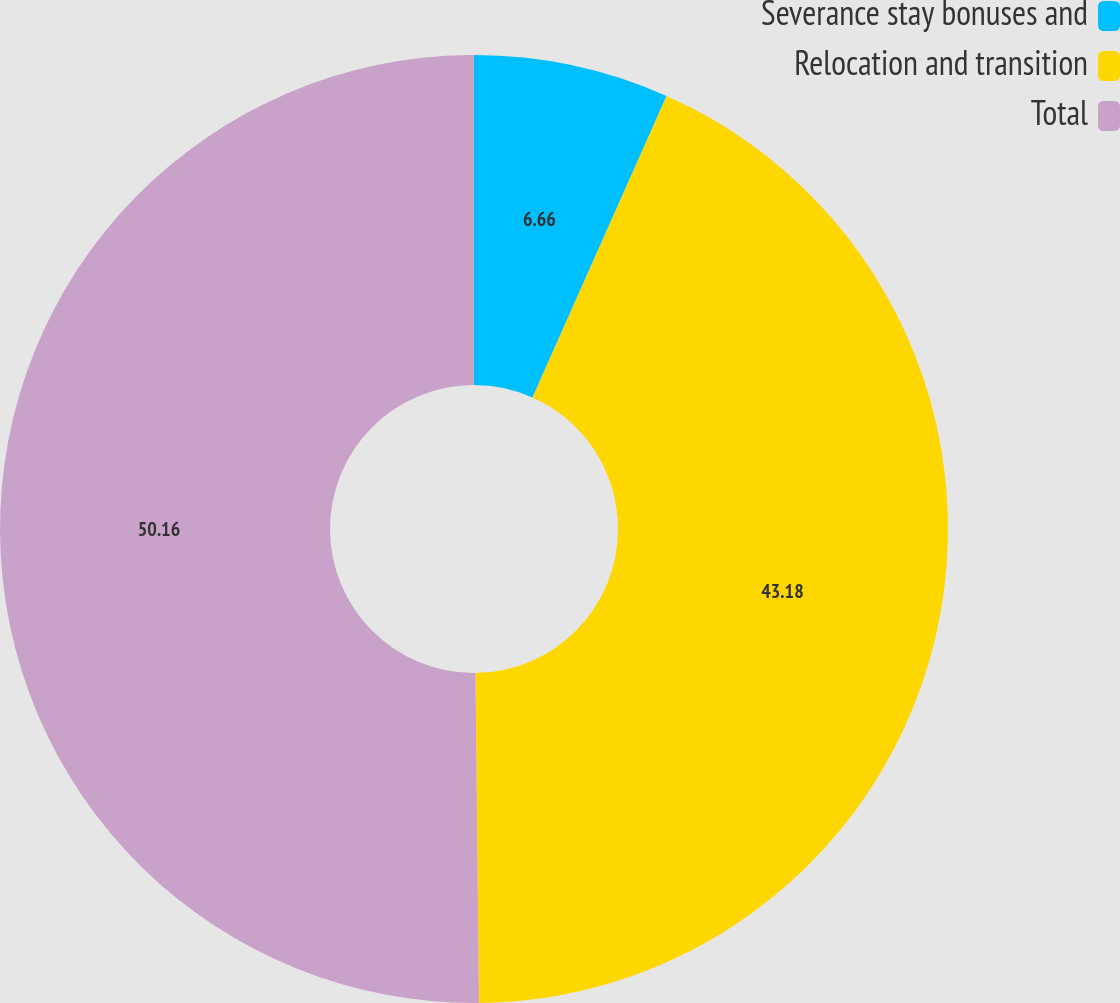<chart> <loc_0><loc_0><loc_500><loc_500><pie_chart><fcel>Severance stay bonuses and<fcel>Relocation and transition<fcel>Total<nl><fcel>6.66%<fcel>43.18%<fcel>50.17%<nl></chart> 